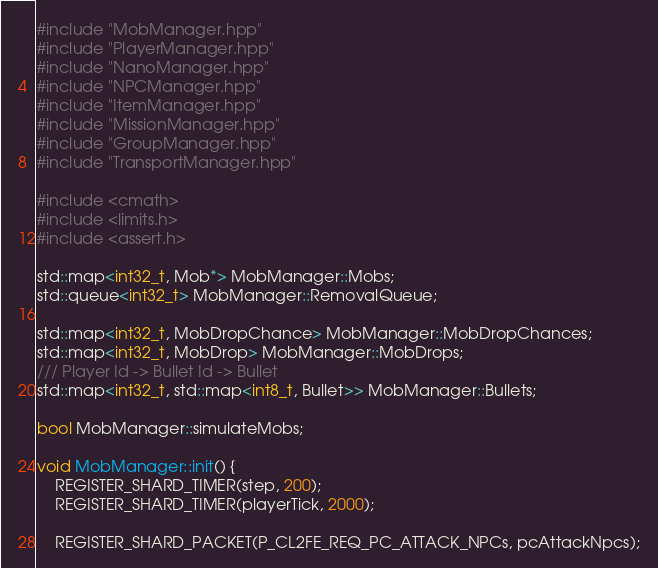Convert code to text. <code><loc_0><loc_0><loc_500><loc_500><_C++_>#include "MobManager.hpp"
#include "PlayerManager.hpp"
#include "NanoManager.hpp"
#include "NPCManager.hpp"
#include "ItemManager.hpp"
#include "MissionManager.hpp"
#include "GroupManager.hpp"
#include "TransportManager.hpp"

#include <cmath>
#include <limits.h>
#include <assert.h>

std::map<int32_t, Mob*> MobManager::Mobs;
std::queue<int32_t> MobManager::RemovalQueue;

std::map<int32_t, MobDropChance> MobManager::MobDropChances;
std::map<int32_t, MobDrop> MobManager::MobDrops;
/// Player Id -> Bullet Id -> Bullet
std::map<int32_t, std::map<int8_t, Bullet>> MobManager::Bullets;

bool MobManager::simulateMobs;

void MobManager::init() {
    REGISTER_SHARD_TIMER(step, 200);
    REGISTER_SHARD_TIMER(playerTick, 2000);

    REGISTER_SHARD_PACKET(P_CL2FE_REQ_PC_ATTACK_NPCs, pcAttackNpcs);
</code> 